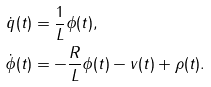<formula> <loc_0><loc_0><loc_500><loc_500>\dot { q } ( t ) & = \frac { 1 } { L } \phi ( t ) , \\ \dot { \phi } ( t ) & = - \frac { R } { L } \phi ( t ) - v ( t ) + \rho ( t ) . \\</formula> 